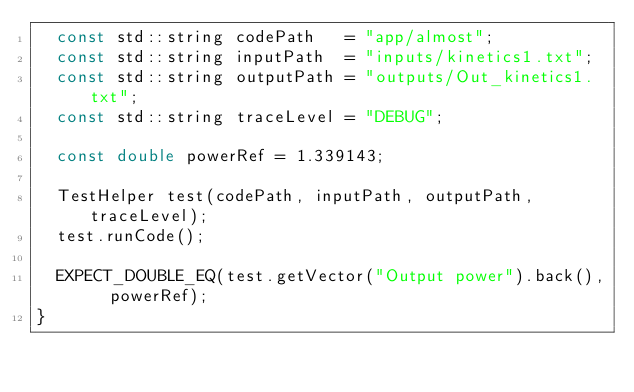<code> <loc_0><loc_0><loc_500><loc_500><_C++_>  const std::string codePath   = "app/almost";
  const std::string inputPath  = "inputs/kinetics1.txt";
  const std::string outputPath = "outputs/Out_kinetics1.txt";
  const std::string traceLevel = "DEBUG";

  const double powerRef = 1.339143;

  TestHelper test(codePath, inputPath, outputPath, traceLevel);
  test.runCode();
  
  EXPECT_DOUBLE_EQ(test.getVector("Output power").back(),  powerRef);
}
</code> 